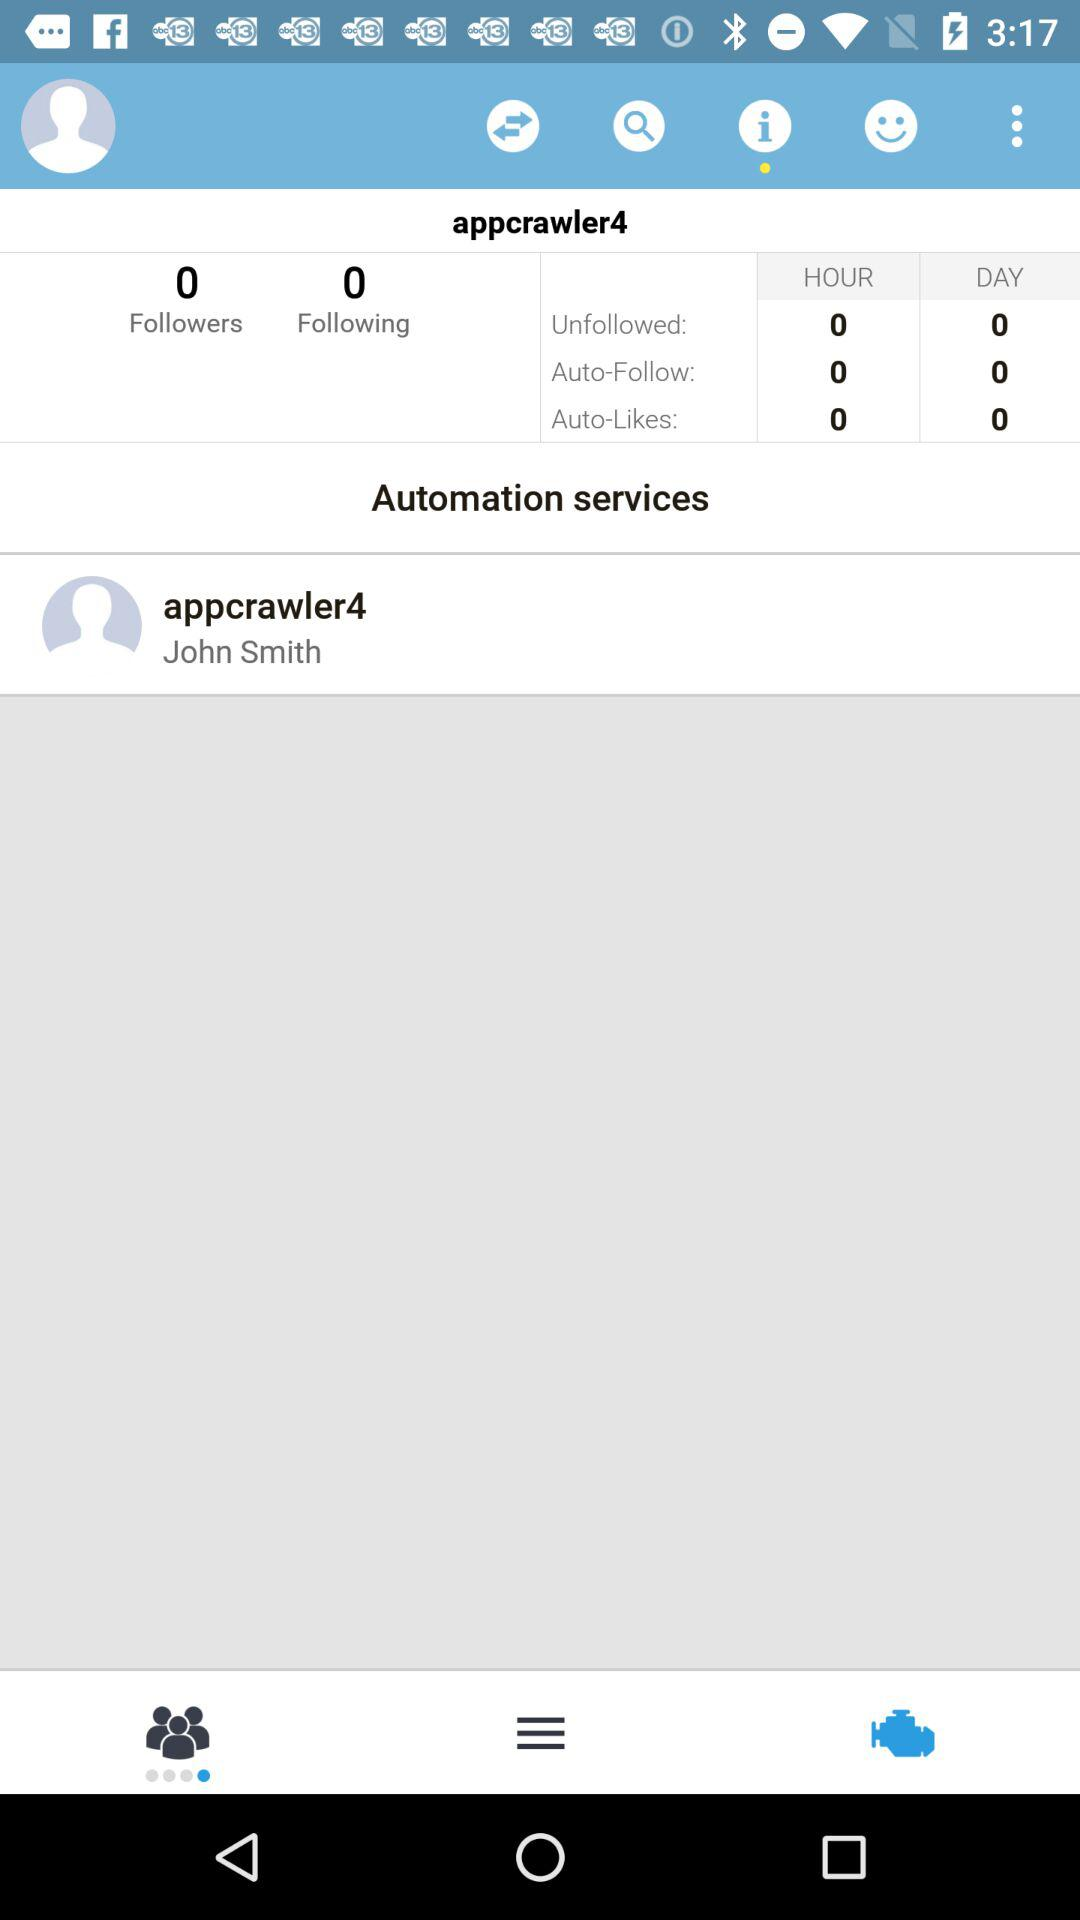What is the count of following? The count of following is 0. 